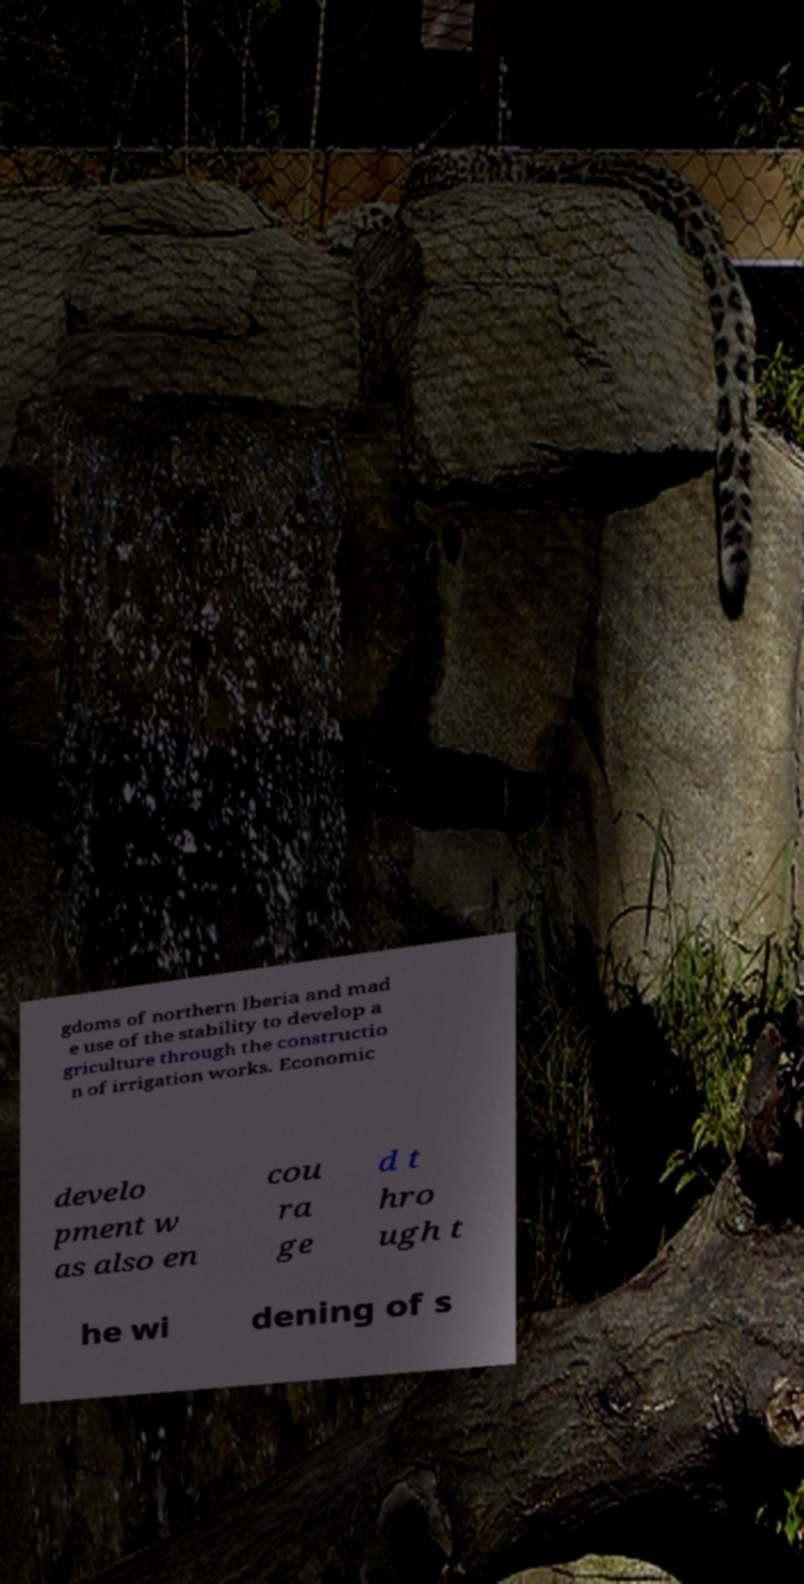Please read and relay the text visible in this image. What does it say? gdoms of northern Iberia and mad e use of the stability to develop a griculture through the constructio n of irrigation works. Economic develo pment w as also en cou ra ge d t hro ugh t he wi dening of s 